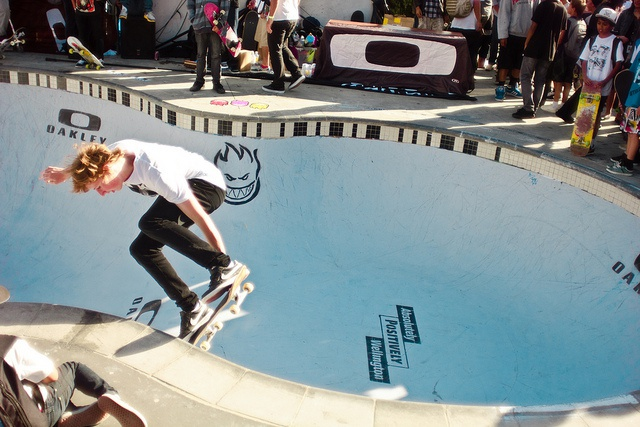Describe the objects in this image and their specific colors. I can see people in gray, black, white, darkgray, and brown tones, people in gray, darkgray, black, and lightblue tones, people in gray, white, maroon, and black tones, people in gray, black, and maroon tones, and people in gray, black, darkgray, and maroon tones in this image. 